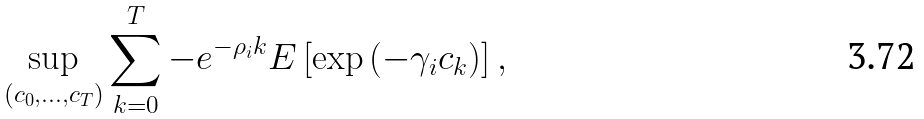Convert formula to latex. <formula><loc_0><loc_0><loc_500><loc_500>\sup _ { ( c _ { 0 } , \dots , c _ { T } ) } \sum _ { k = 0 } ^ { T } - e ^ { - \rho _ { i } k } E \left [ \exp \left ( - \gamma _ { i } c _ { k } \right ) \right ] ,</formula> 